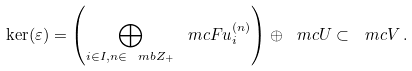Convert formula to latex. <formula><loc_0><loc_0><loc_500><loc_500>\ker ( \varepsilon ) = \left ( \bigoplus _ { i \in I , n \in \ m b Z _ { + } } \ m c F u _ { i } ^ { ( n ) } \right ) \oplus \ m c U \subset \ m c V \, .</formula> 